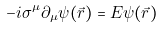<formula> <loc_0><loc_0><loc_500><loc_500>- i \sigma ^ { \mu } \partial _ { \mu } \psi ( \vec { r } ) = E \psi ( \vec { r } )</formula> 